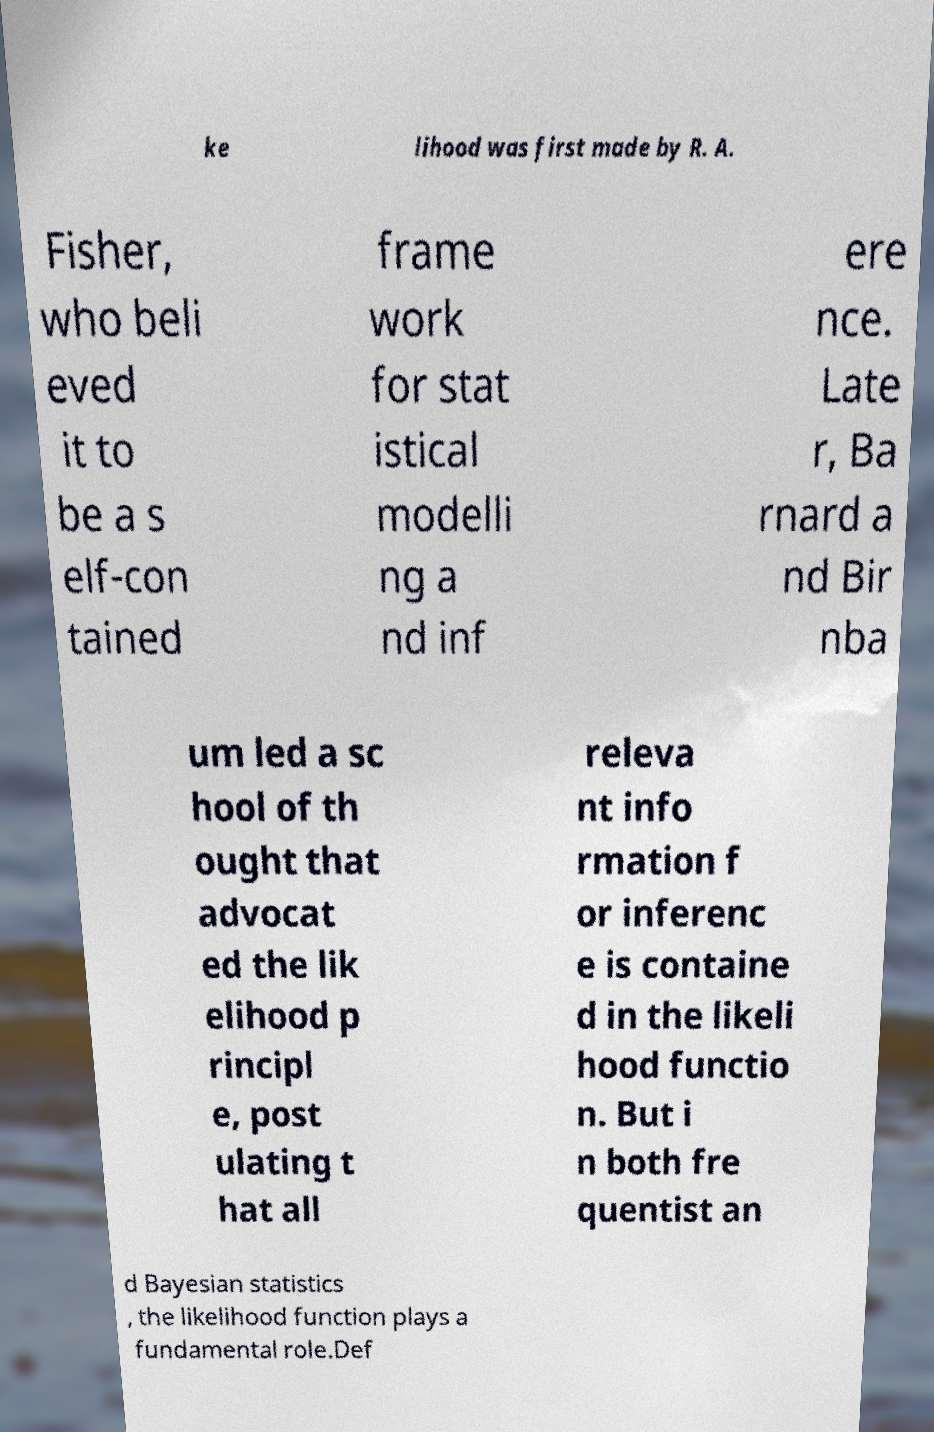Could you extract and type out the text from this image? ke lihood was first made by R. A. Fisher, who beli eved it to be a s elf-con tained frame work for stat istical modelli ng a nd inf ere nce. Late r, Ba rnard a nd Bir nba um led a sc hool of th ought that advocat ed the lik elihood p rincipl e, post ulating t hat all releva nt info rmation f or inferenc e is containe d in the likeli hood functio n. But i n both fre quentist an d Bayesian statistics , the likelihood function plays a fundamental role.Def 